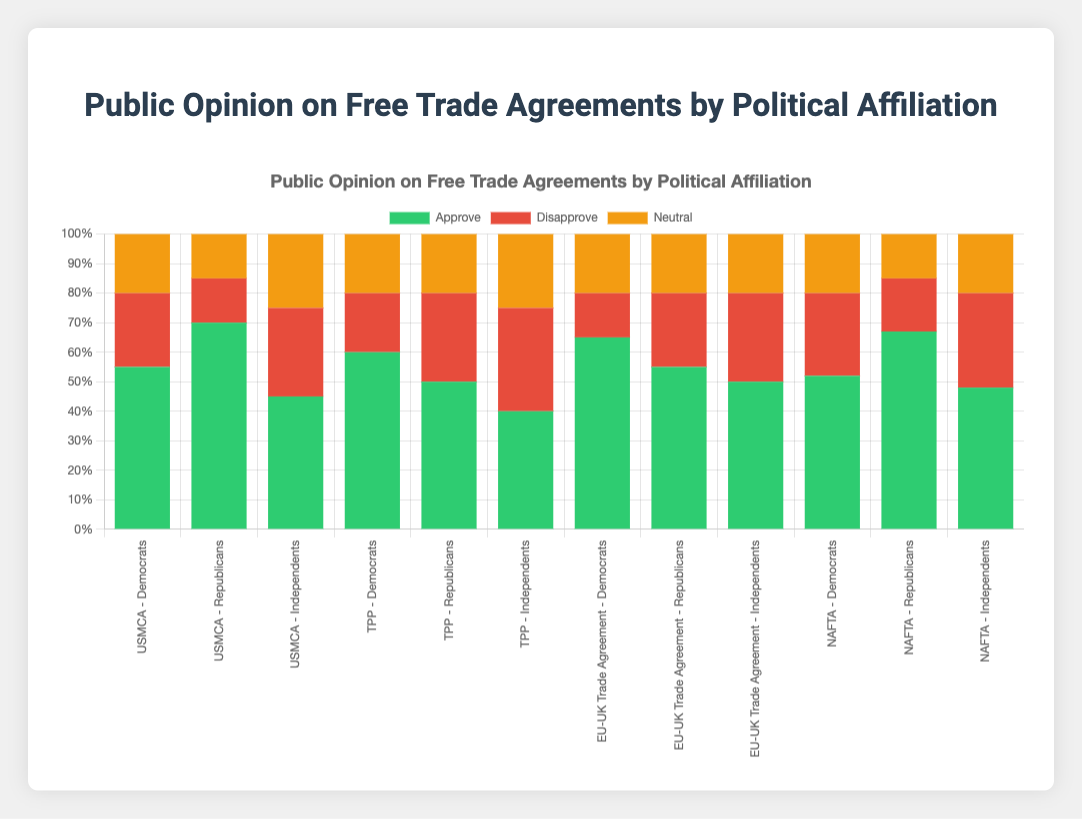What is the political affiliation with the highest disapproval percentage for the TPP agreement? For the TPP trade agreement, look at the disapproval percentages for Democrats (20%), Republicans (30%), and Independents (35%). The highest value is for Independents.
Answer: Independents Which political affiliation has the highest approval percentage for the EU-UK Trade Agreement? For the EU-UK Trade Agreement, look at the approval percentages for Democrats (65%), Republicans (55%), and Independents (50%). The highest value is for Democrats.
Answer: Democrats Compare the neutral opinions for USMCA and NAFTA across Independents. Which has a higher neutral percentage, and by how much? The neutral percentage among Independents for USMCA is 25%, and for NAFTA, it's 20%. The difference is 25% - 20% = 5%.
Answer: USMCA by 5% What is the average approval percentage for Democrats across all trade agreements? Add the approval percentages for Democrats: USMCA (55%), TPP (60%), EU-UK Trade Agreement (65%), and NAFTA (52%). The total is 55 + 60 + 65 + 52 = 232. Divide by the number of agreements (4) to get the average: 232 / 4 = 58%.
Answer: 58% Which trade agreement shows the smallest difference in approval percentages between Republicans and Independents? Calculate the differences in approval percentages between Republicans and Independents for each agreement: USMCA (70% - 45% = 25%), TPP (50% - 40% = 10%), EU-UK Trade Agreement (55% - 50% = 5%), and NAFTA (67% - 48% = 19%). The smallest difference is 5% for the EU-UK Trade Agreement.
Answer: EU-UK Trade Agreement How do the approval rates for the TPP agreement compare between Democrats and Republicans? For the TPP trade agreement, look at the approval percentages for Democrats (60%) and Republicans (50%). Compare the values: Democrats have a 10% higher approval rate than Republicans.
Answer: Democrats have a 10% higher approval rate What is the combined percentage for neutral opinions for all political affiliations on the NAFTA agreement? For NAFTA, add the neutral percentages for Democrats (20%), Republicans (15%), and Independents (20%): 20 + 15 + 20 = 55%.
Answer: 55% Which visual attribute indicates the neutral opinion percentages on the stacked bar chart? Neutral opinion percentages are indicated by the sections of the stacked bars colored in yellow.
Answer: Yellow What is the total disapproval percentage for the USMCA agreement across all political affiliations? Add the disapproval percentages for USMCA across Democrats (25%), Republicans (15%), and Independents (30%): 25 + 15 + 30 = 70%.
Answer: 70% 